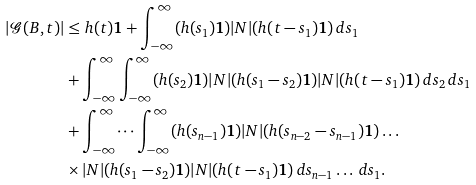<formula> <loc_0><loc_0><loc_500><loc_500>| \mathcal { G } ( B , t ) | & \leq h ( t ) \mathbf 1 + \int _ { - \infty } ^ { \infty } ( h ( s _ { 1 } ) \mathbf 1 ) | N | ( h ( t - s _ { 1 } ) \mathbf 1 ) \, d s _ { 1 } \\ & + \int _ { - \infty } ^ { \infty } \int _ { - \infty } ^ { \infty } ( h ( s _ { 2 } ) \mathbf 1 ) | N | ( h ( s _ { 1 } - s _ { 2 } ) \mathbf 1 ) | N | ( h ( t - s _ { 1 } ) \mathbf 1 ) \, d s _ { 2 } \, d s _ { 1 } \\ & + \int _ { - \infty } ^ { \infty } \dots \int _ { - \infty } ^ { \infty } ( h ( s _ { n - 1 } ) \mathbf 1 ) | N | ( h ( s _ { n - 2 } - s _ { n - 1 } ) \mathbf 1 ) \dots \\ & \times | N | ( h ( s _ { 1 } - s _ { 2 } ) \mathbf 1 ) | N | ( h ( t - s _ { 1 } ) \mathbf 1 ) \, d s _ { n - 1 } \dots \, d s _ { 1 } .</formula> 